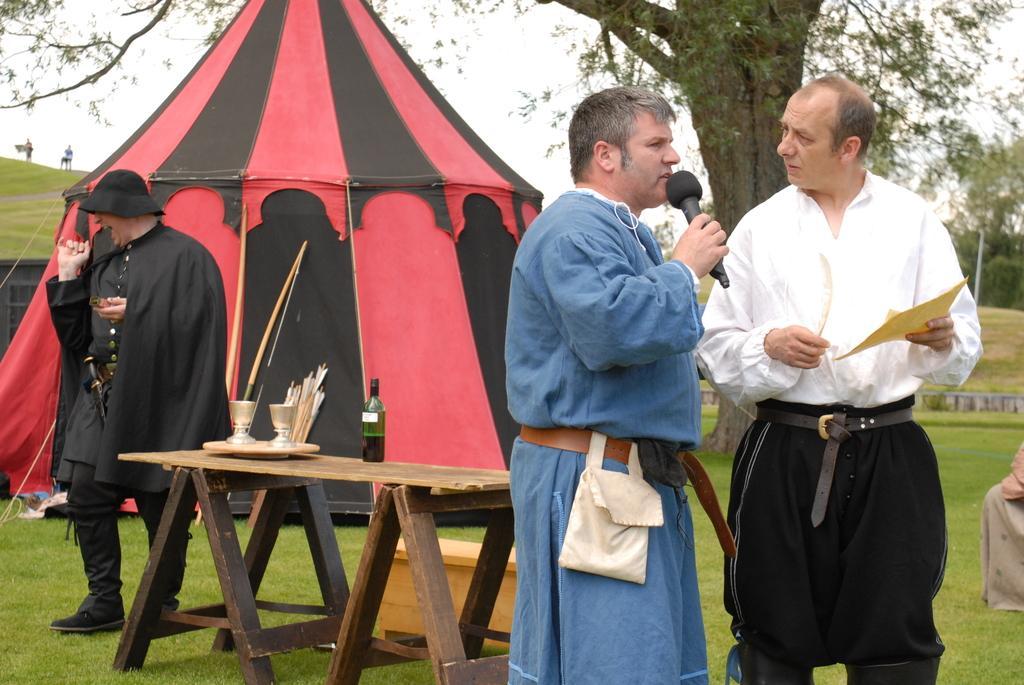Can you describe this image briefly? In this picture we can see a table with a bottle, glasses on it, tent, trees and three people standing on the grass, mic, paper, sword, cap, bag and in the background we can see two people and the sky. 